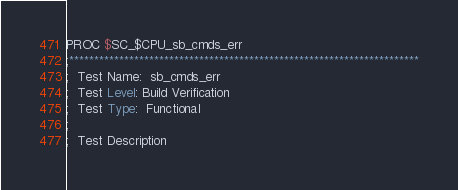Convert code to text. <code><loc_0><loc_0><loc_500><loc_500><_SQL_>PROC $SC_$CPU_sb_cmds_err
;**********************************************************************
;  Test Name:  sb_cmds_err
;  Test Level: Build Verification
;  Test Type:  Functional
;
;  Test Description</code> 